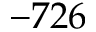<formula> <loc_0><loc_0><loc_500><loc_500>- 7 2 6</formula> 